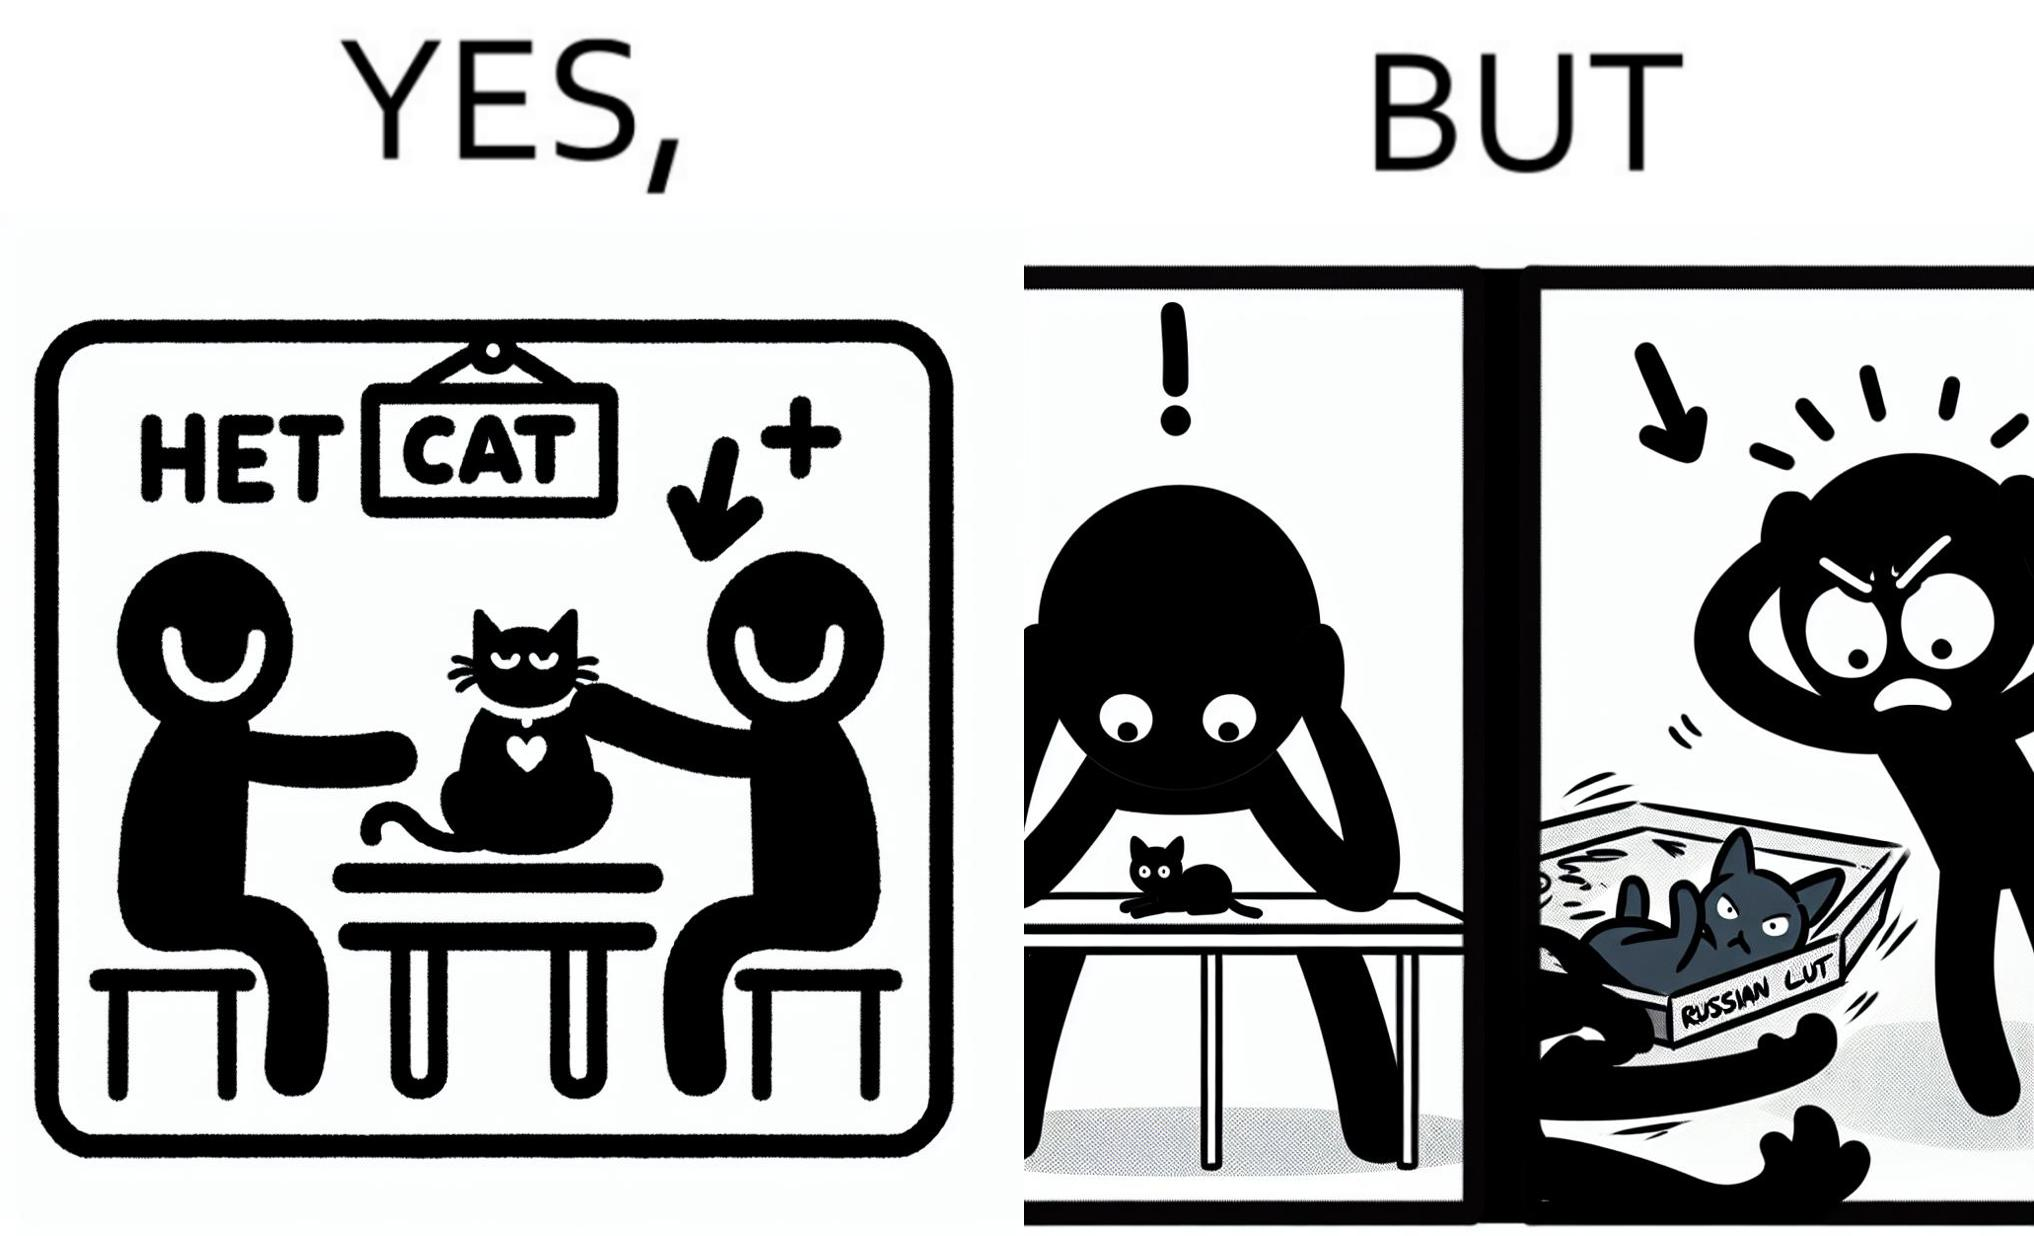Describe the content of this image. The image is confusing, as initially, when the label reads "Blue Cat", the people are happy and are petting tha cat, but as soon as one of them realizes that the entire text reads "Russian Blue Cat", they seem to worried, and one of them throws away the cat. For some reason, the word "Russian" is a trigger word for them. 